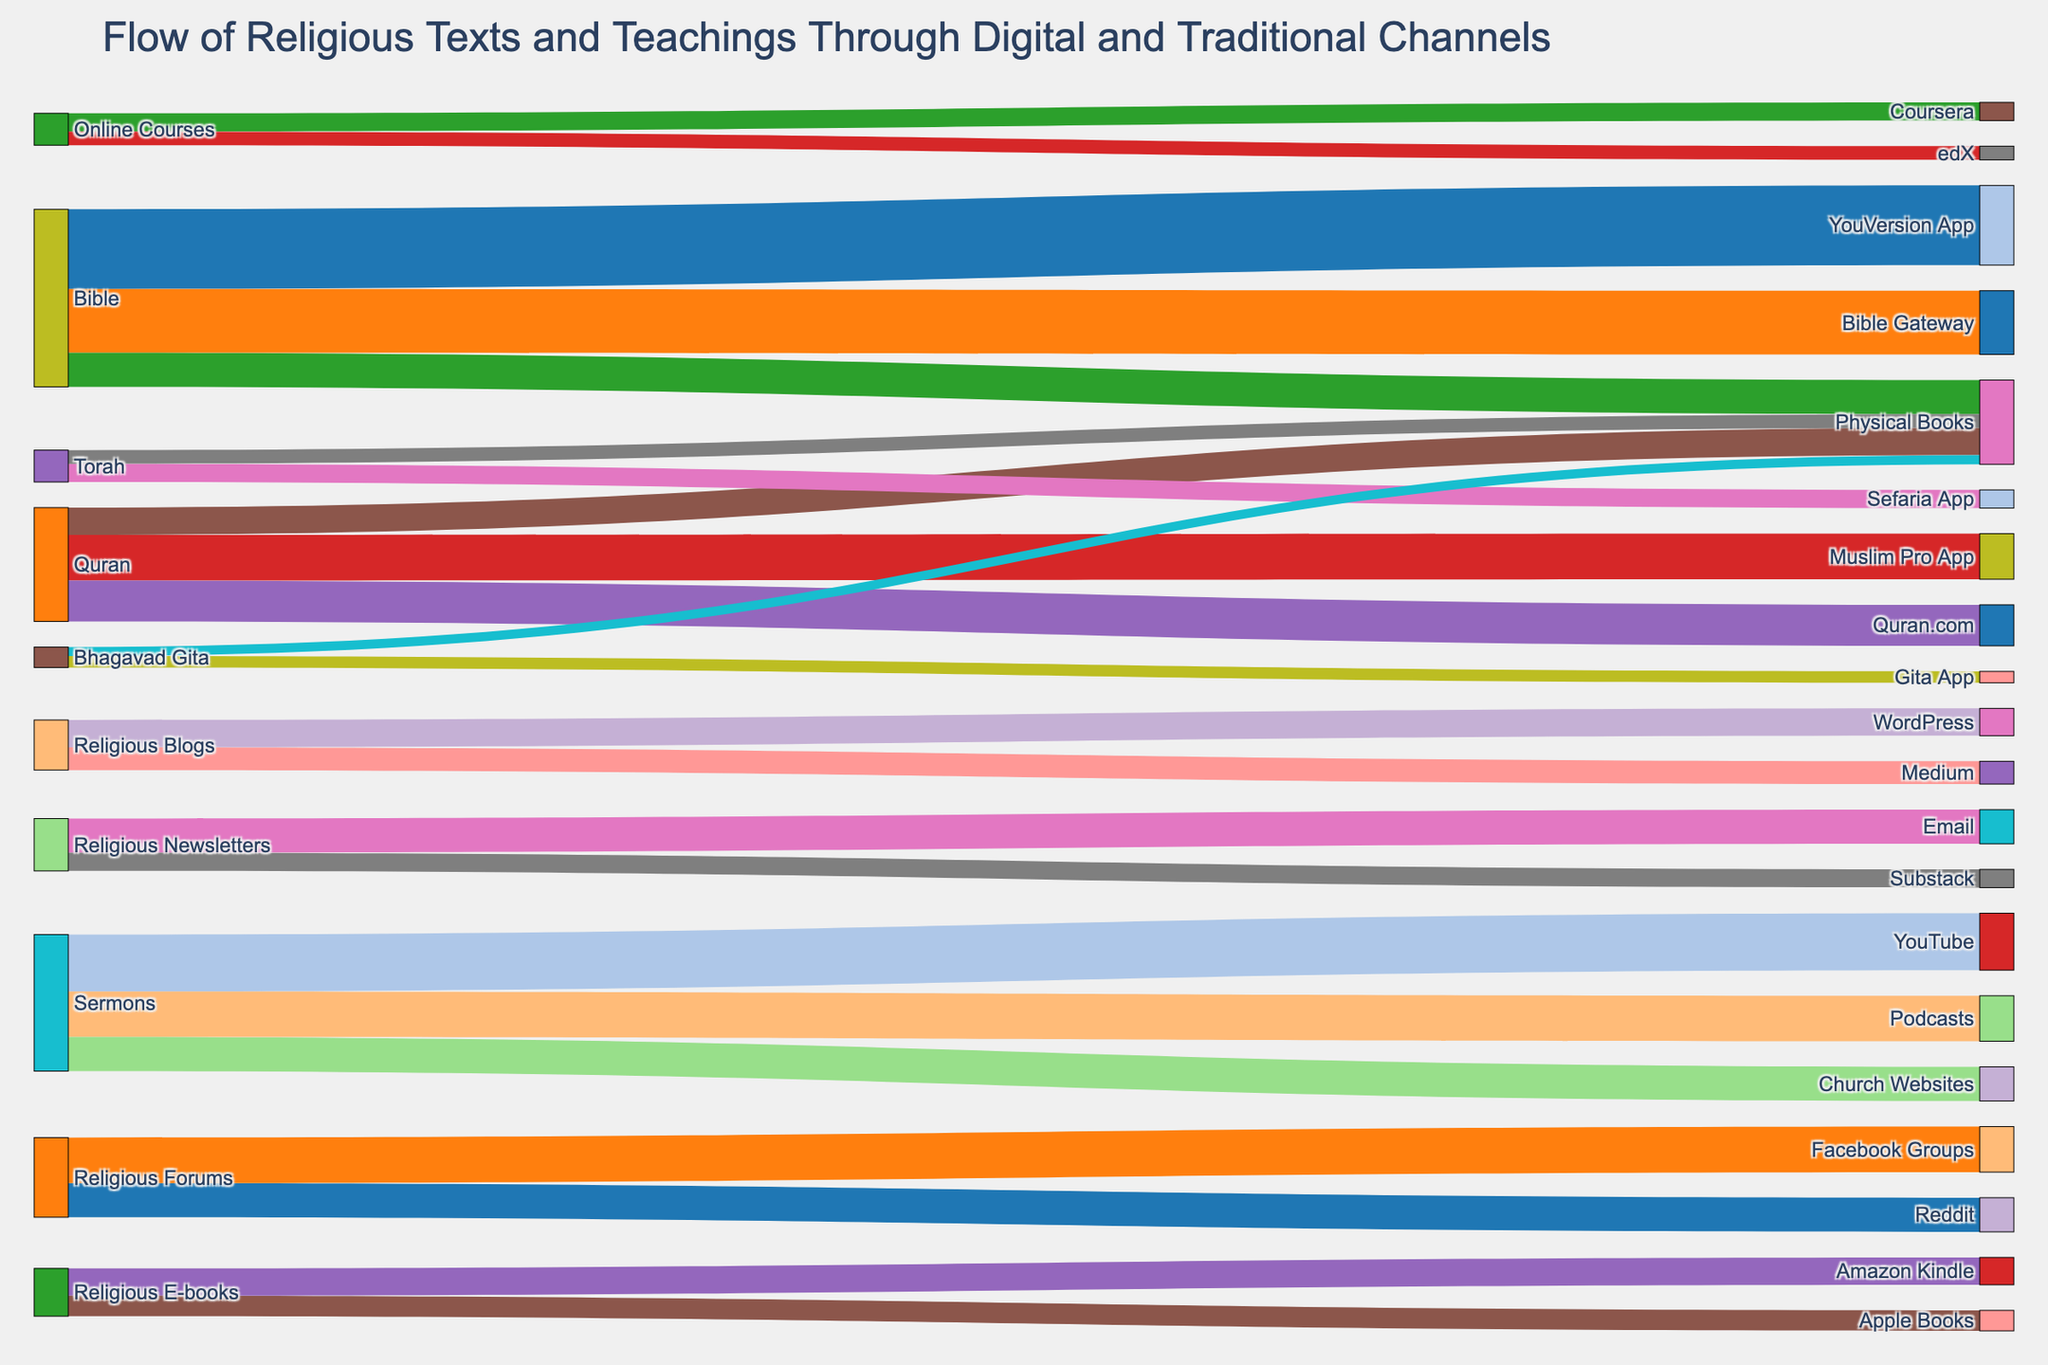What is the flow with the highest value from the Bible to a digital platform? The highest value flow from the Bible to a digital platform is to the YouVersion App with a value of 3,500,000. This can be seen by comparing the values of flows originating from the Bible to different targets.
Answer: YouVersion App, 3,500,000 How many total flows are there from the Bible? To find the total number of flows from the Bible, count all the links originating from the Bible in the diagram: Bible to YouVersion App, Bible Gateway, and Physical Books.
Answer: 3 What is the combined value of flows related to the Quran? The combined value is the sum of all flows originating from or targeting the Quran: Muslim Pro App (2,000,000) + Quran.com (1,800,000) + Physical Books (1,200,000) = 5,000,000.
Answer: 5,000,000 Which traditional medium has the highest total value across all religious texts? Examine the total value of flows targeting Physical Books across all texts: Bible (1,500,000) + Quran (1,200,000) + Torah (600,000) + Bhagavad Gita (400,000) for a total of 3,700,000. Compare this with other traditional media channels, if present.
Answer: Physical Books Which digital platform receives the largest value flow for sermons? Compare the values of flows related to sermons: YouTube (2,500,000), Podcasts (2,000,000), and Church Websites (1,500,000). The largest value is towards YouTube.
Answer: YouTube How does the flow to YouTube for sermons compare with the combined flow to all other channels for sermons? The flow to YouTube is 2,500,000. The combined flow to other channels (Podcasts and Church Websites) is 2,000,000 + 1,500,000 = 3,500,000. The combined flow to other channels is larger.
Answer: 2,500,000 vs 3,500,000 Which religious text has the least digital flow, and what is the value? Compare the total digital flows from each religious text: Bhagavad Gita to Gita App (500,000). It has the least total digital flow.
Answer: Bhagavad Gita, 500,000 What is the total value of flows to online courses platforms? Add up the values of flows targeting Coursera (800,000) and edX (600,000) for online courses.
Answer: 1,400,000 Which digital platform associated with religious forums has the highest value flow? Compare the values of flows related to religious forums: Reddit (1,500,000) and Facebook Groups (2,000,000). The highest value flow is to Facebook Groups.
Answer: Facebook Groups What is the difference in value between religious newsletters received by Email and those on Substack? Subtract the flow value to Substack (800,000) from the flow value to Email (1,500,000) for religious newsletters.
Answer: 700,000 